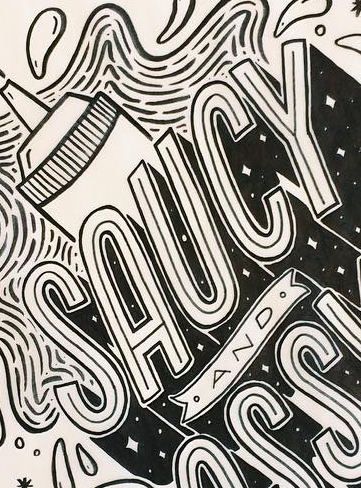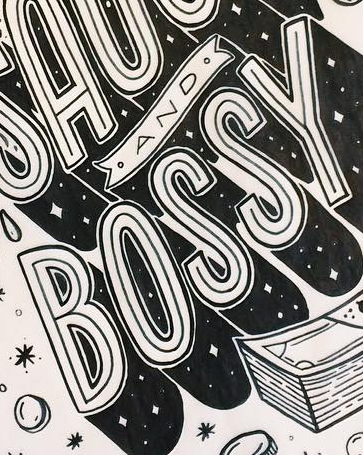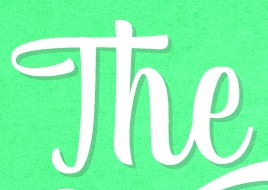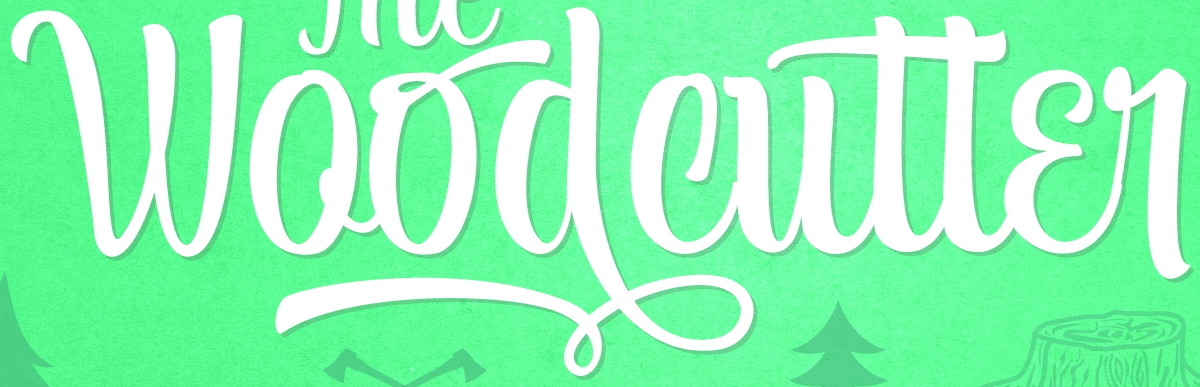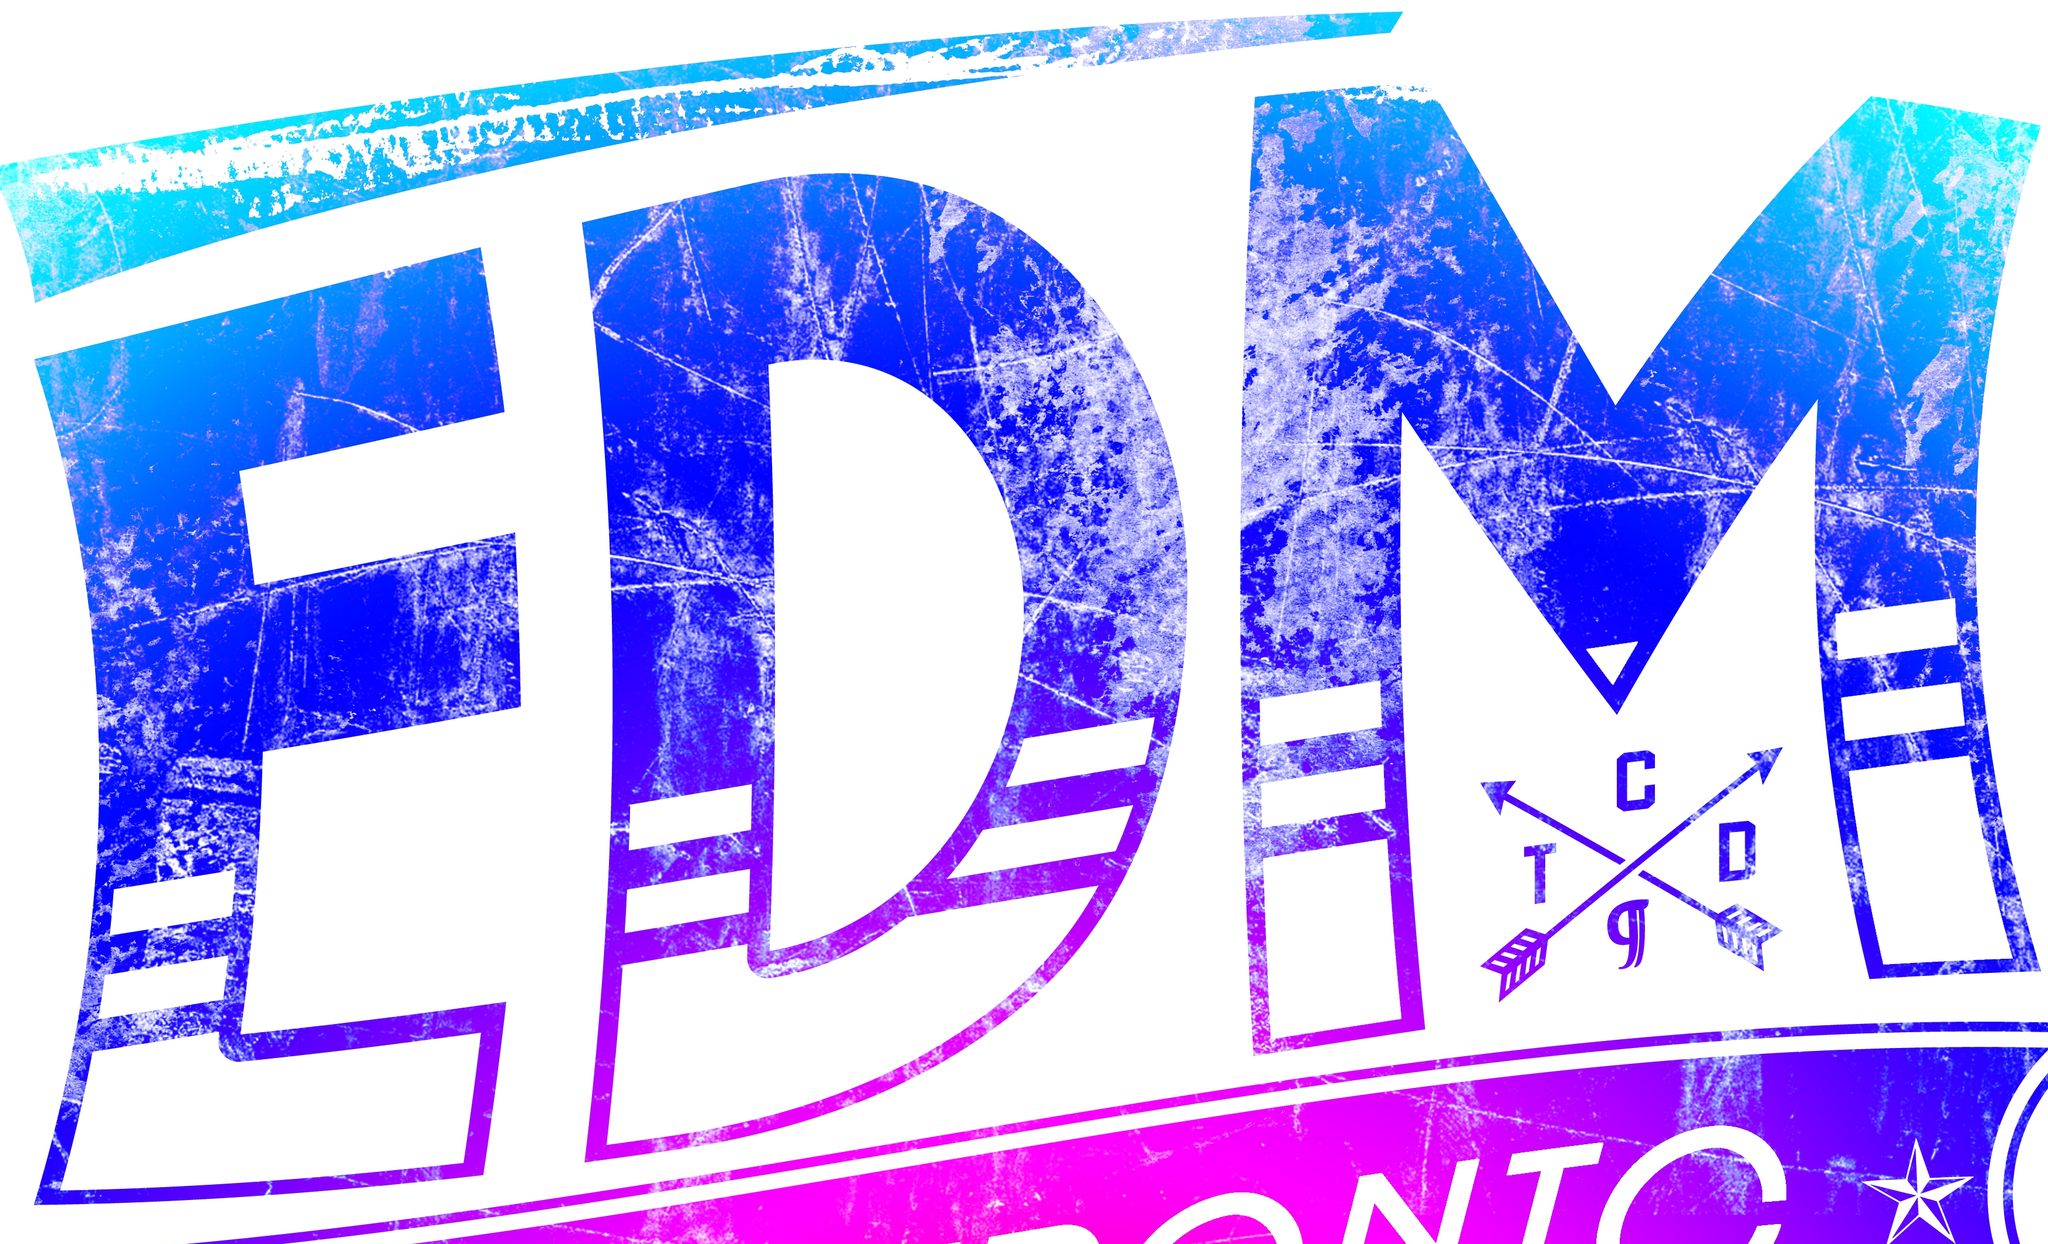What words can you see in these images in sequence, separated by a semicolon? SAUCY; BOSSY; The; Woodcutter; EDM 